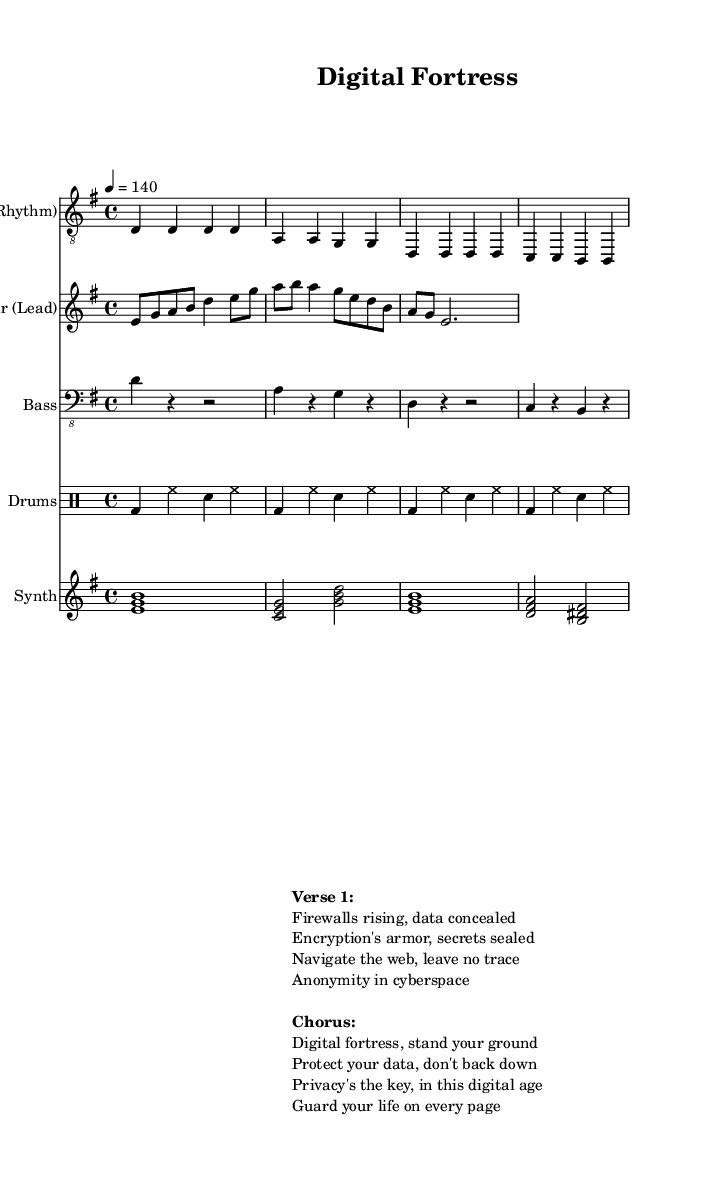What is the key signature of this music? The key signature is E minor, which has one sharp (F#). It is indicated at the beginning of the staff.
Answer: E minor What is the time signature of the piece? The time signature is 4/4, which means there are four beats in each measure. This is indicated at the beginning of the score.
Answer: 4/4 What is the tempo of the music? The tempo marking indicates a speed of 140 beats per minute, which is noted as "4 = 140" in the global settings.
Answer: 140 How many measures are in the rhythm guitar part? The rhythm guitar part contains four measures, as counted in the provided music notation.
Answer: 4 How many distinct instruments are written in the score? There are five distinct instruments indicated in the score: Rhythm Guitar, Lead Guitar, Bass, Drums, and Synth. Each one is on a separate staff.
Answer: 5 What theme do the lyrics in the chorus emphasize? The lyrics of the chorus emphasize the importance of protecting data and privacy in the digital world, as highlighted in phrases like "Protect your data" and "Privacy's the key."
Answer: Protecting data and privacy What is the primary focus of the song's lyrics? The primary focus of the song's lyrics is on cybersecurity and maintaining digital privacy, illustrated through phrases about firewalls, encryption, and anonymity.
Answer: Cybersecurity and digital privacy 